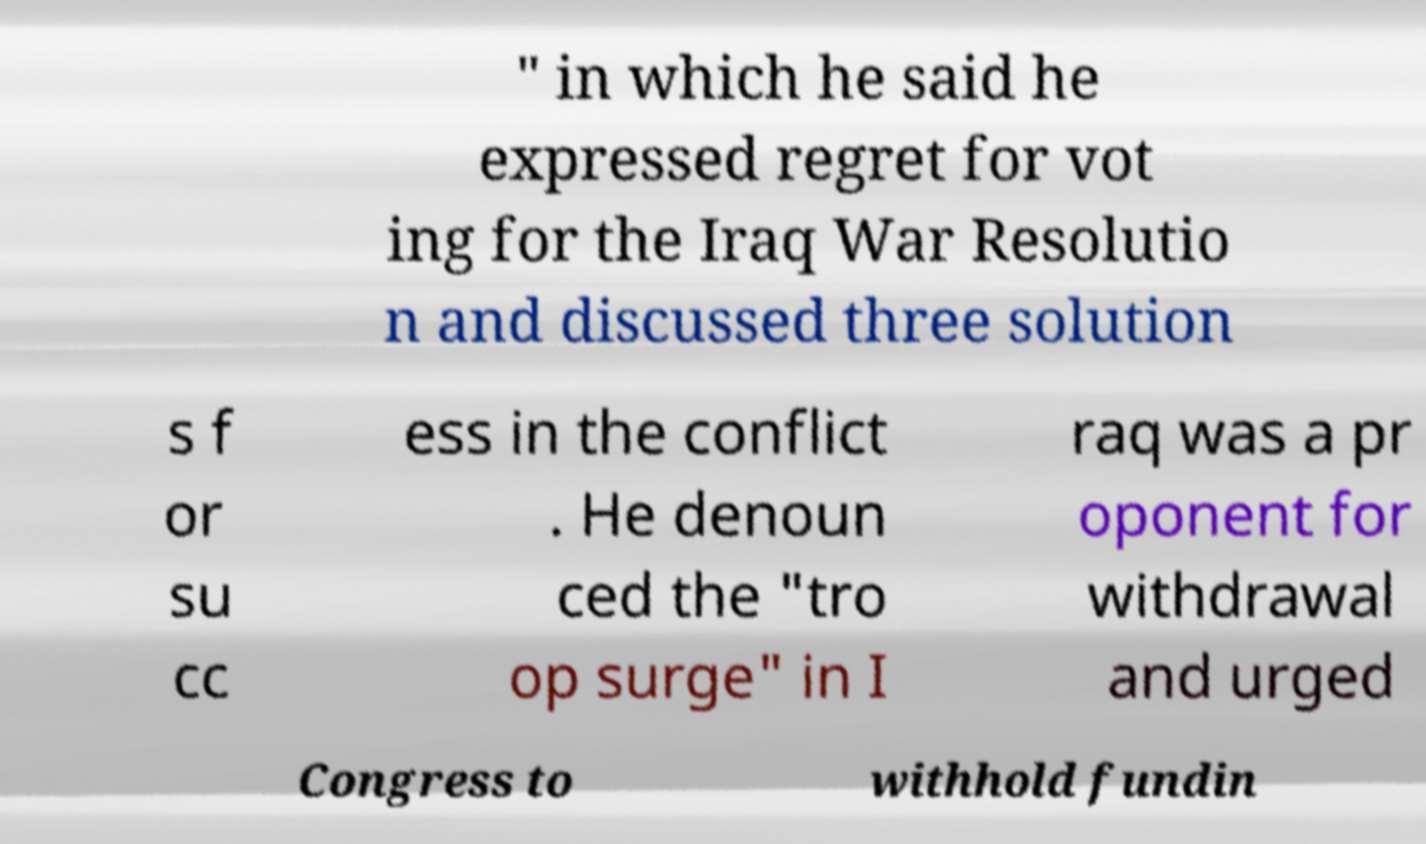Can you accurately transcribe the text from the provided image for me? " in which he said he expressed regret for vot ing for the Iraq War Resolutio n and discussed three solution s f or su cc ess in the conflict . He denoun ced the "tro op surge" in I raq was a pr oponent for withdrawal and urged Congress to withhold fundin 